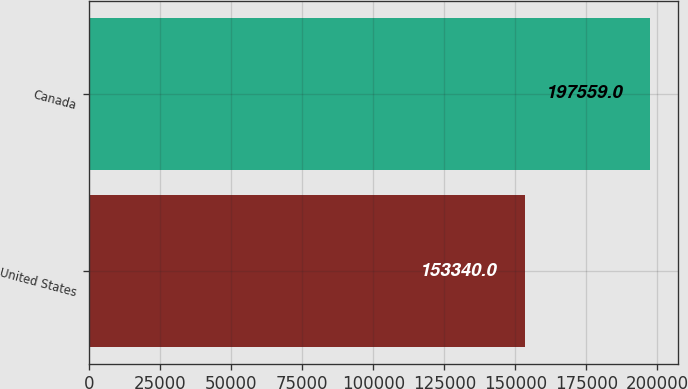Convert chart to OTSL. <chart><loc_0><loc_0><loc_500><loc_500><bar_chart><fcel>United States<fcel>Canada<nl><fcel>153340<fcel>197559<nl></chart> 